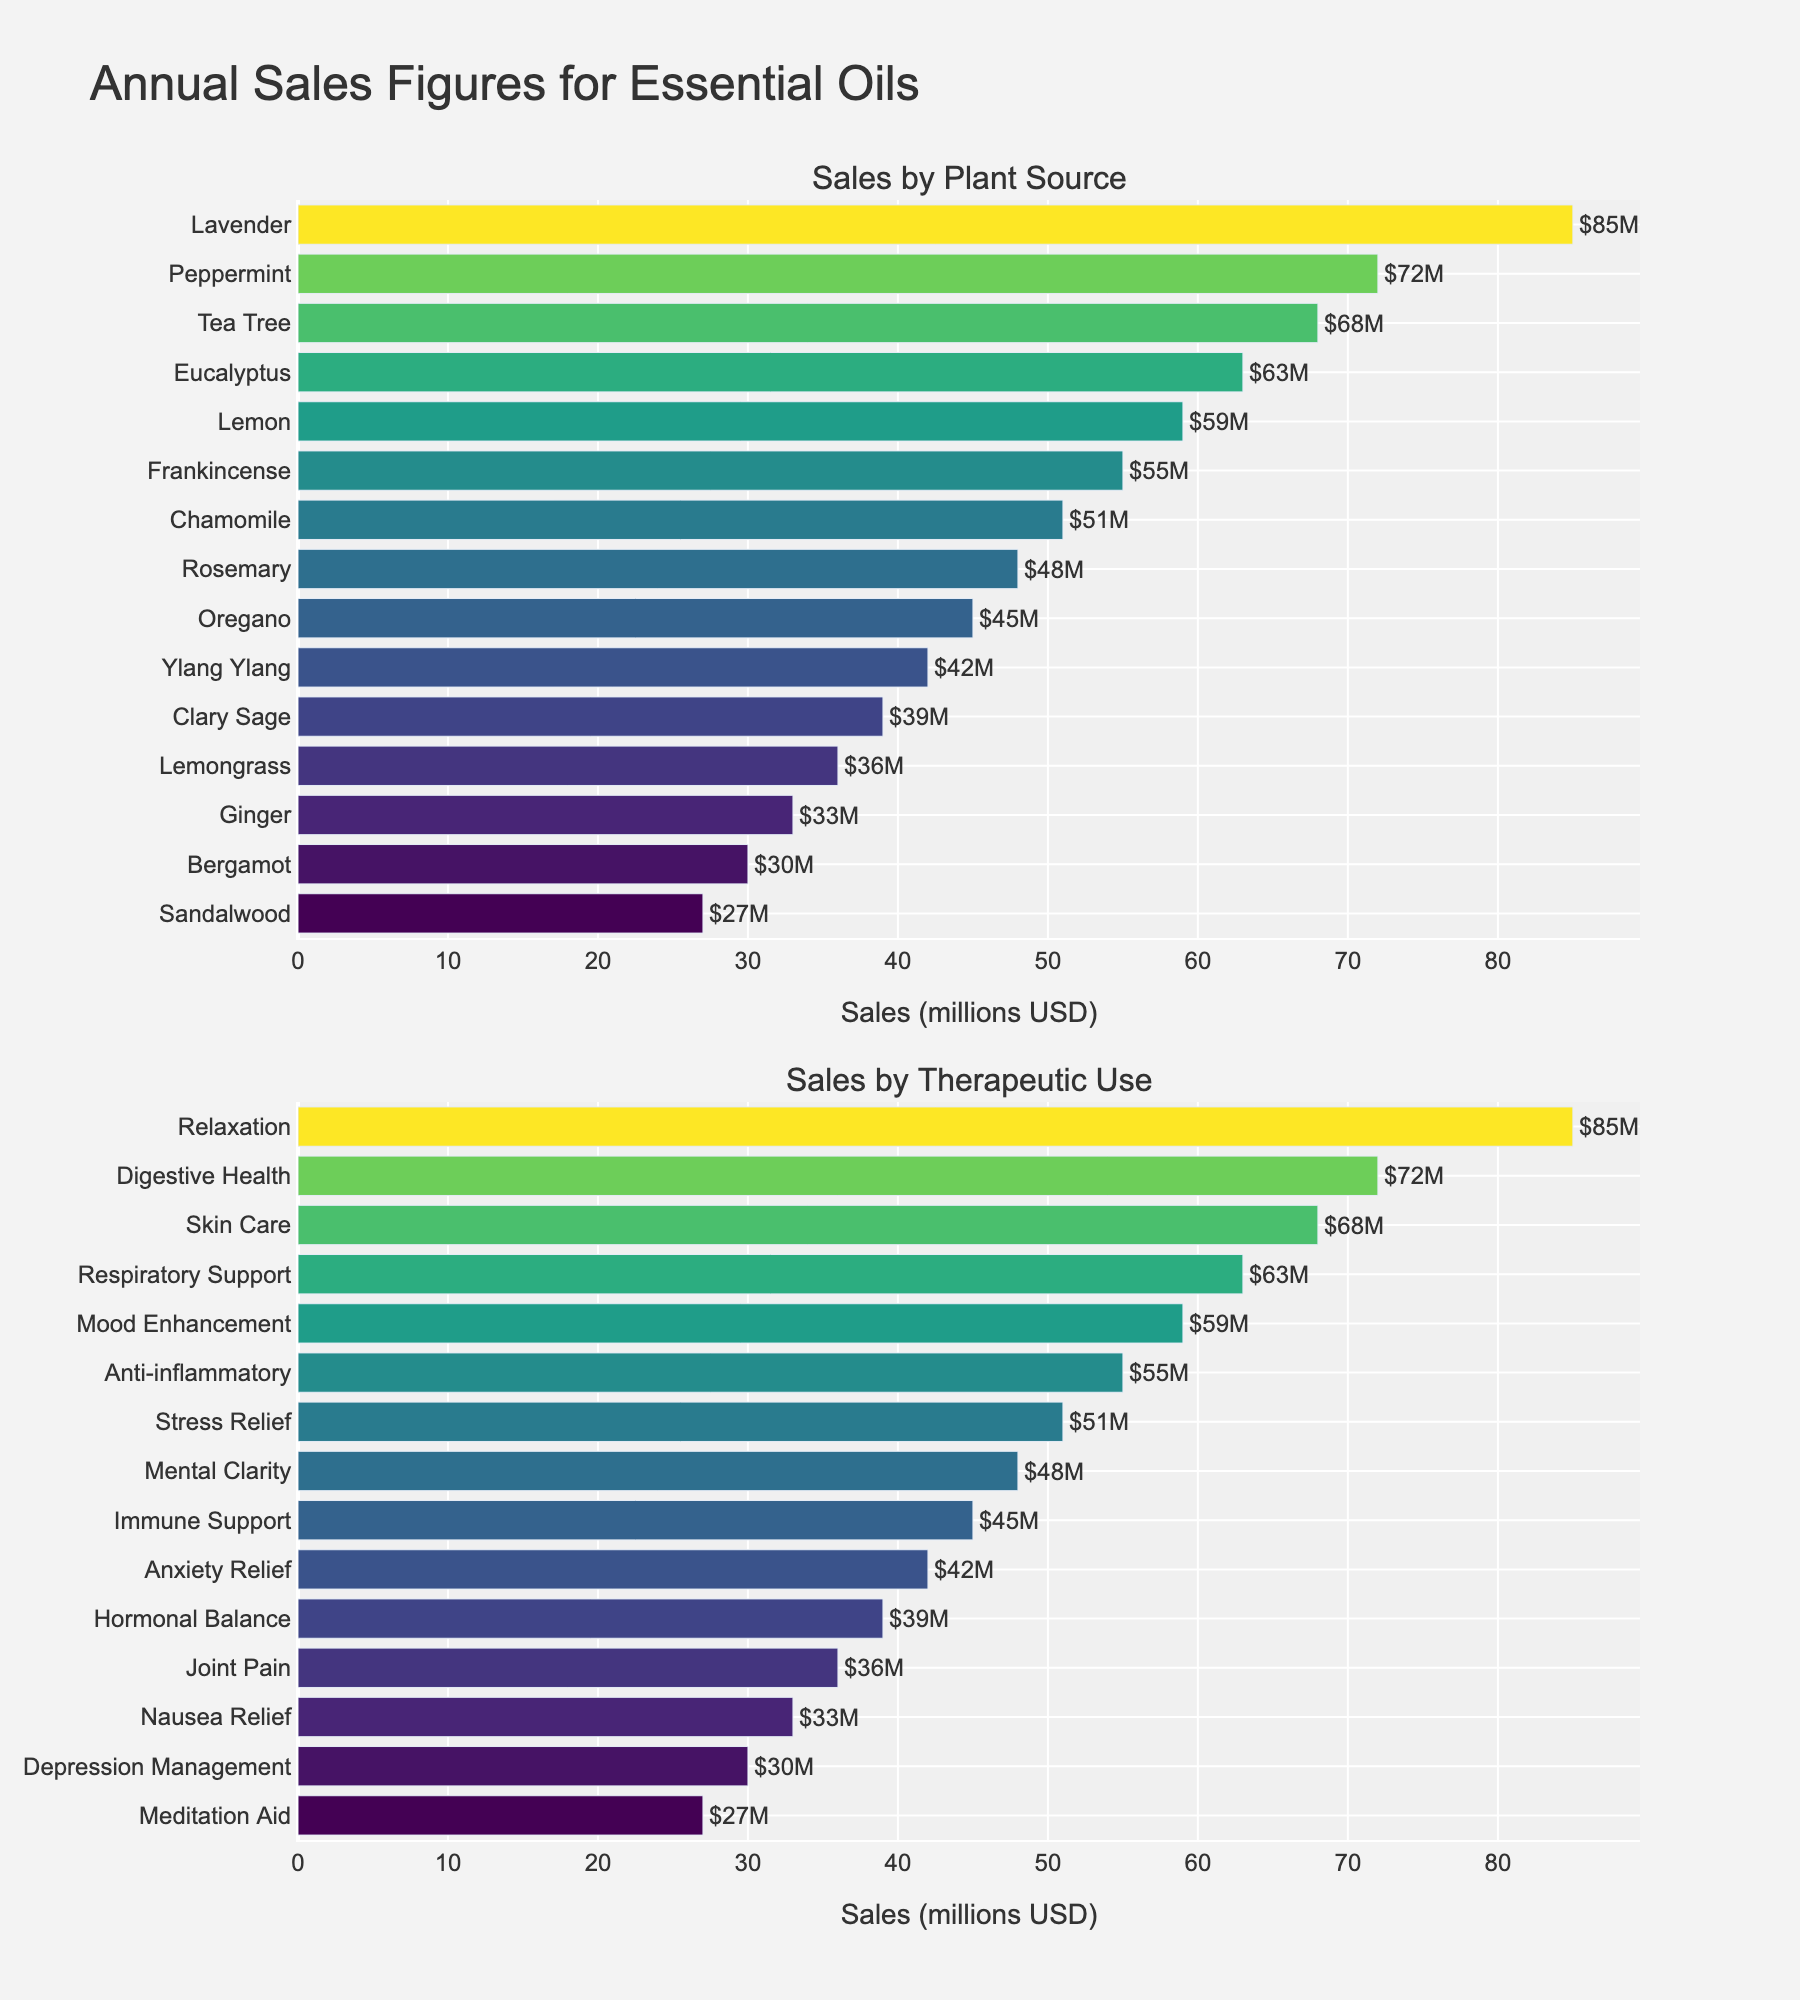What is the title of the figure? The title is usually prominently displayed at the top of the figure. It describes the purpose or main topic of the visual.
Answer: "Annual Sales Figures for Essential Oils" Which essential oil has the highest sales by plant source? By looking at the first subplot, we can identify that the bar corresponding to "Lavender" extends the farthest to the right.
Answer: Lavender What are the top three therapeutic uses by sales? In the second subplot, identifying the three longest bars (positions) and reading their labels will give us the top three uses.
Answer: Relaxation, Digestive Health, Skin Care What is the combined sales figure for Eucalyptus and Tea Tree essential oils? Add the sales figures of Eucalyptus ($63M) and Tea Tree ($68M) as shown on the first subplot.
Answer: $131M Which has higher sales: Stress Relief or Mood Enhancement essential oils? In the second subplot, compare the lengths of the bars for Stress Relief ($51M) and Mood Enhancement ($59M).
Answer: Mood Enhancement Which essential oil plant source has the lowest sales figure? In the first subplot, identify the bar that is shortest or furthest to the left, which is Sandalwood.
Answer: Sandalwood How does the sales figure for Lavender compare to Frankincense in terms of percentage? Calculate the percentage by dividing Lavender's sales ($85M) by Frankincense's sales ($55M) and then multiply by 100.
Answer: Approximately 154.55% Are sales for Bergamot higher or lower than for Ginger in their therapeutic uses? In the second subplot, compare the lengths of the bars for Bergamot ($30M) and Ginger ($33M).
Answer: Lower What is the difference in sales between the highest and lowest therapeutic uses? Subtract the sales figure for Meditation Aid ($27M) from Relaxation ($85M), which are the highest and lowest therapeutic uses, respectively.
Answer: $58M How many different essential oil plant sources are displayed in the figure? Count the unique labels in the first subplot, ensuring each plant source is tallied once.
Answer: 15 